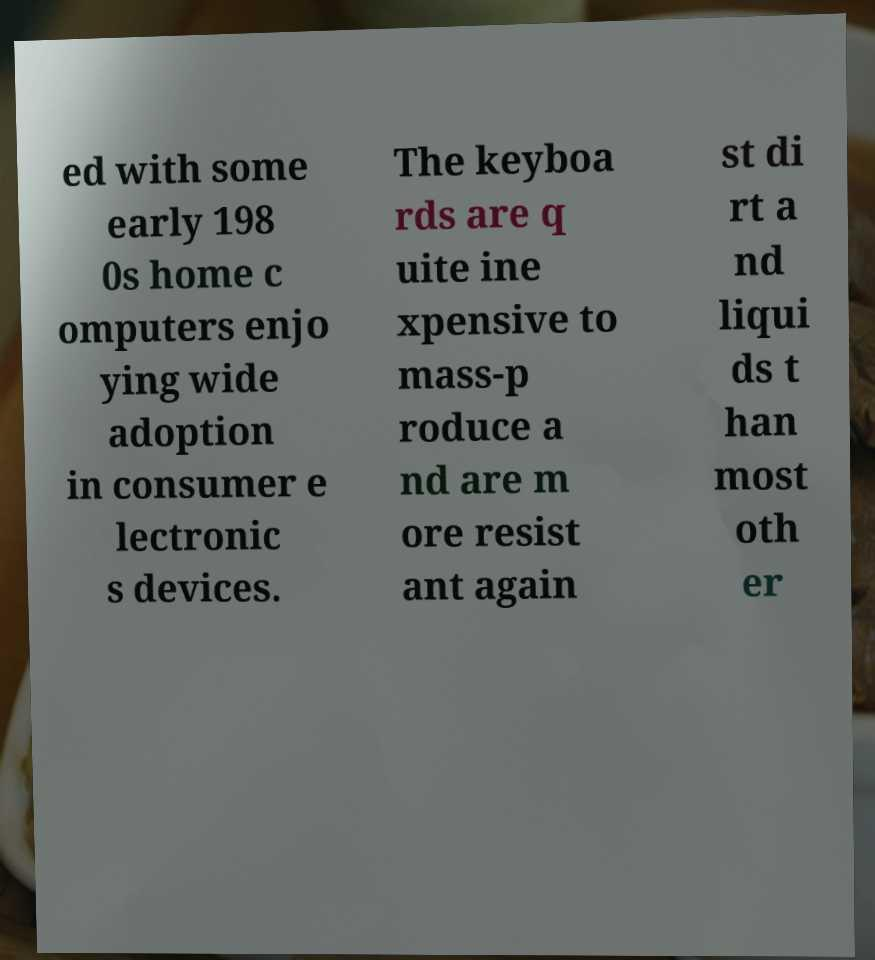What messages or text are displayed in this image? I need them in a readable, typed format. ed with some early 198 0s home c omputers enjo ying wide adoption in consumer e lectronic s devices. The keyboa rds are q uite ine xpensive to mass-p roduce a nd are m ore resist ant again st di rt a nd liqui ds t han most oth er 